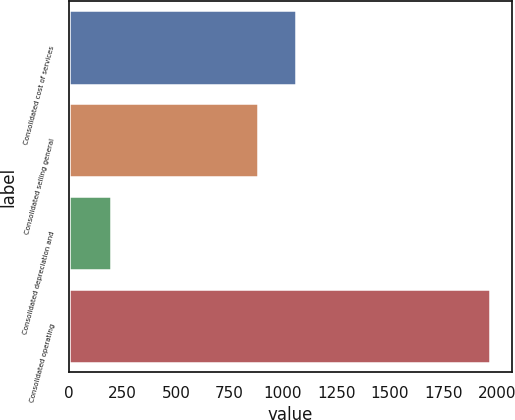Convert chart. <chart><loc_0><loc_0><loc_500><loc_500><bar_chart><fcel>Consolidated cost of services<fcel>Consolidated selling general<fcel>Consolidated depreciation and<fcel>Consolidated operating<nl><fcel>1061.47<fcel>884.3<fcel>198<fcel>1969.7<nl></chart> 